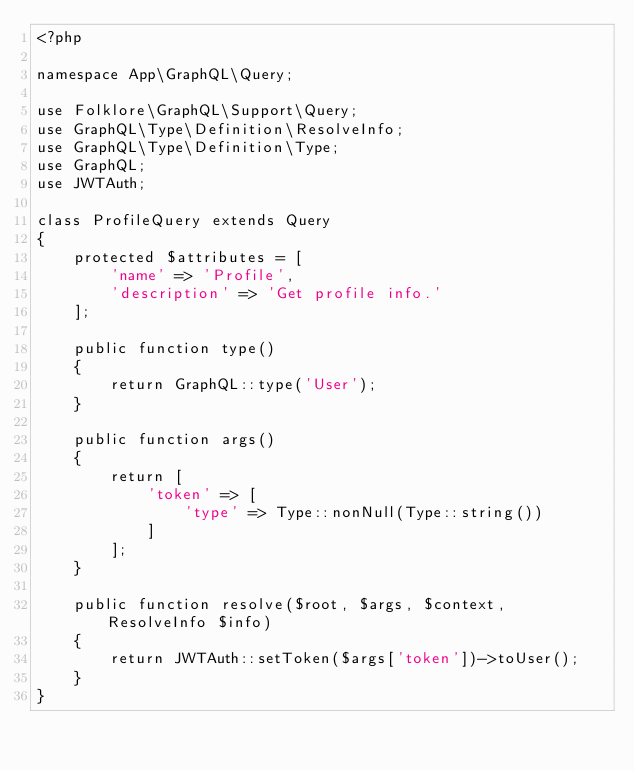Convert code to text. <code><loc_0><loc_0><loc_500><loc_500><_PHP_><?php

namespace App\GraphQL\Query;

use Folklore\GraphQL\Support\Query;
use GraphQL\Type\Definition\ResolveInfo;
use GraphQL\Type\Definition\Type;
use GraphQL;
use JWTAuth;

class ProfileQuery extends Query
{
    protected $attributes = [
        'name' => 'Profile',
        'description' => 'Get profile info.'
    ];

    public function type()
    {
        return GraphQL::type('User');
    }

    public function args()
    {
        return [
            'token' => [
                'type' => Type::nonNull(Type::string())
            ]
        ];
    }

    public function resolve($root, $args, $context, ResolveInfo $info)
    {
        return JWTAuth::setToken($args['token'])->toUser();
    }
}
</code> 